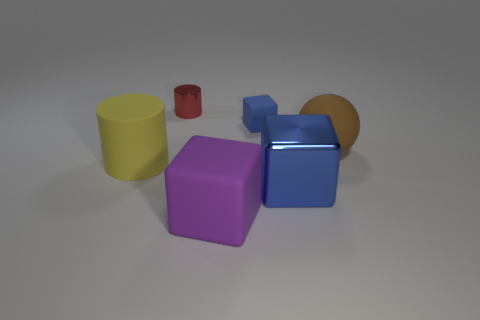What textures do the objects in the image appear to have? The objects appear to have varying textures: the yellow and red cylinders have a matte finish, the blue cube looks shiny and reflective, suggesting a smooth surface, and the purple cube appears to have a slightly softer, rubbery texture. Do you think these textures affect the way light interacts with the objects? Absolutely. The matte surfaces scatter light more diffusely, reducing reflections, while the shiny surface of the blue cube reflects light more directly, creating highlights and making it seem brighter. The rubbery texture of the purple cube likely reflects light in a less uniform manner, giving it a distinctive look compared to the other objects. 